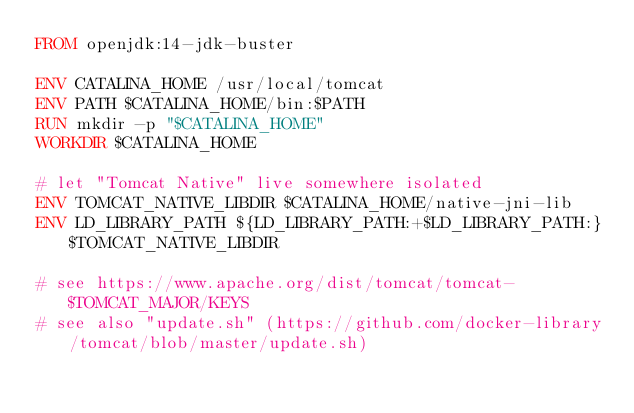Convert code to text. <code><loc_0><loc_0><loc_500><loc_500><_Dockerfile_>FROM openjdk:14-jdk-buster

ENV CATALINA_HOME /usr/local/tomcat
ENV PATH $CATALINA_HOME/bin:$PATH
RUN mkdir -p "$CATALINA_HOME"
WORKDIR $CATALINA_HOME

# let "Tomcat Native" live somewhere isolated
ENV TOMCAT_NATIVE_LIBDIR $CATALINA_HOME/native-jni-lib
ENV LD_LIBRARY_PATH ${LD_LIBRARY_PATH:+$LD_LIBRARY_PATH:}$TOMCAT_NATIVE_LIBDIR

# see https://www.apache.org/dist/tomcat/tomcat-$TOMCAT_MAJOR/KEYS
# see also "update.sh" (https://github.com/docker-library/tomcat/blob/master/update.sh)</code> 